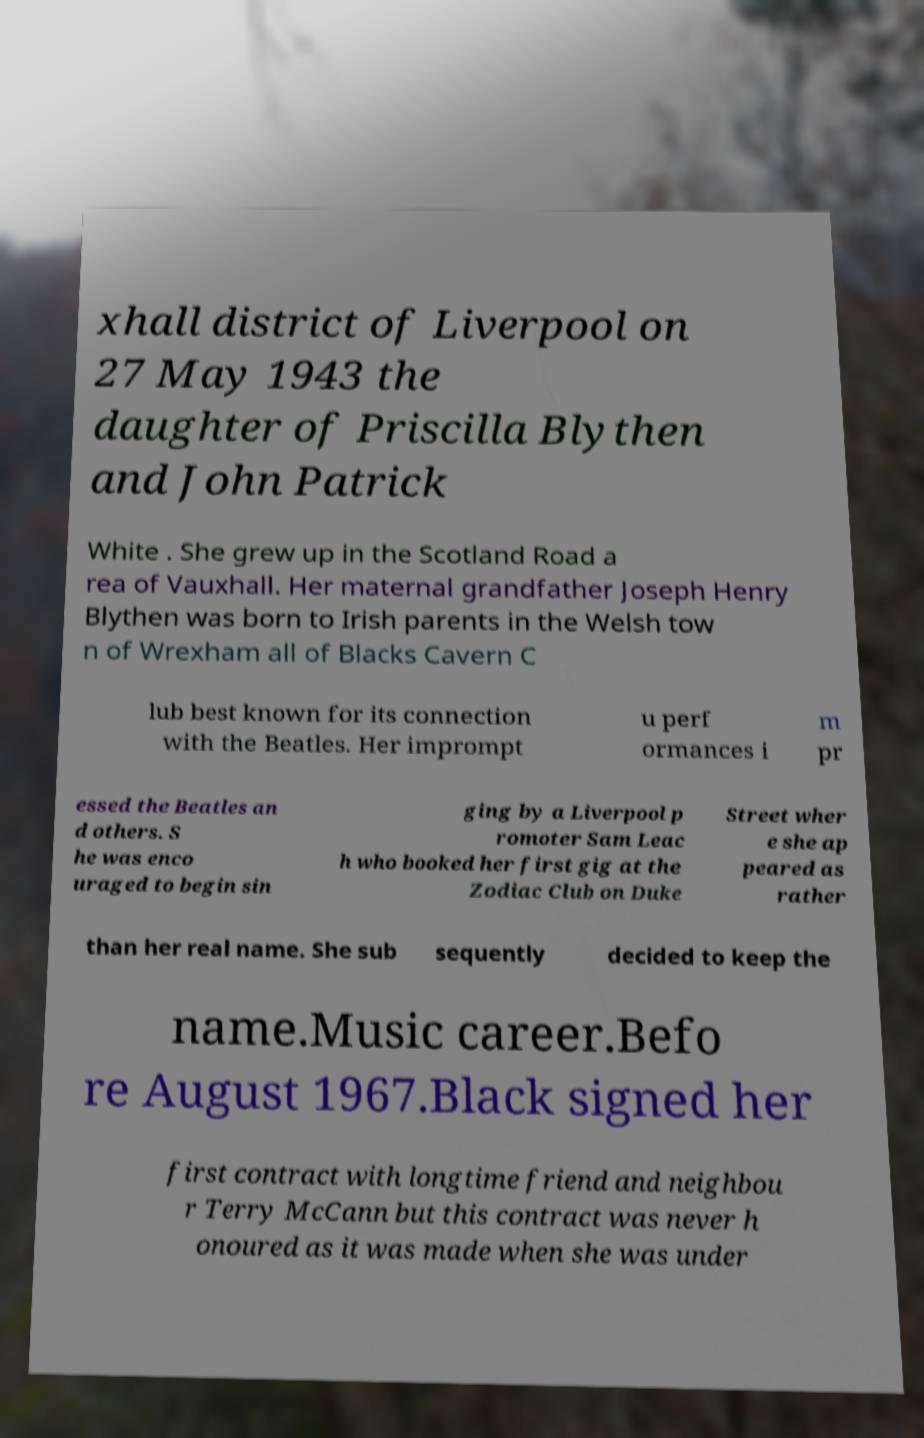Please read and relay the text visible in this image. What does it say? xhall district of Liverpool on 27 May 1943 the daughter of Priscilla Blythen and John Patrick White . She grew up in the Scotland Road a rea of Vauxhall. Her maternal grandfather Joseph Henry Blythen was born to Irish parents in the Welsh tow n of Wrexham all of Blacks Cavern C lub best known for its connection with the Beatles. Her imprompt u perf ormances i m pr essed the Beatles an d others. S he was enco uraged to begin sin ging by a Liverpool p romoter Sam Leac h who booked her first gig at the Zodiac Club on Duke Street wher e she ap peared as rather than her real name. She sub sequently decided to keep the name.Music career.Befo re August 1967.Black signed her first contract with longtime friend and neighbou r Terry McCann but this contract was never h onoured as it was made when she was under 